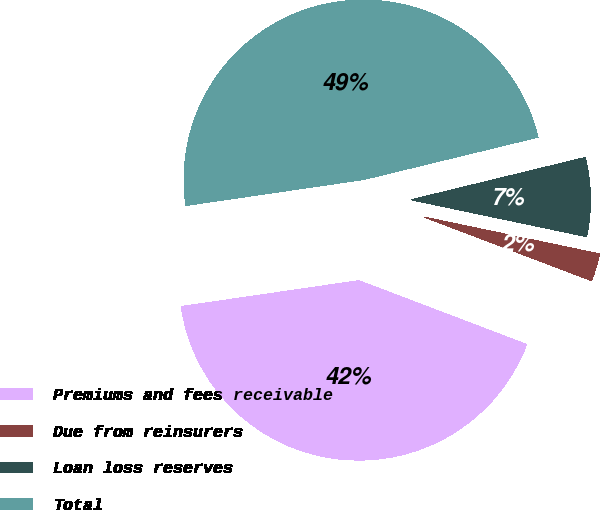Convert chart. <chart><loc_0><loc_0><loc_500><loc_500><pie_chart><fcel>Premiums and fees receivable<fcel>Due from reinsurers<fcel>Loan loss reserves<fcel>Total<nl><fcel>41.91%<fcel>2.49%<fcel>7.09%<fcel>48.51%<nl></chart> 